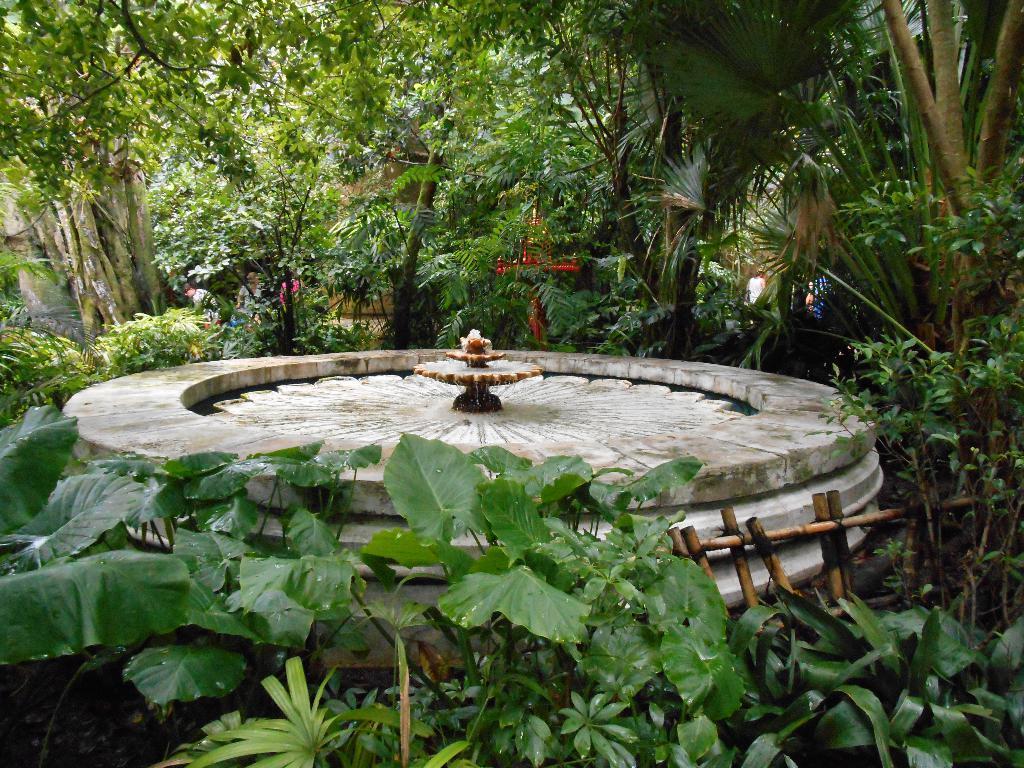Describe this image in one or two sentences. In this image we can see a fountain between the trees and a wooden fence near the fountain and in the background there are few people and a wall. 